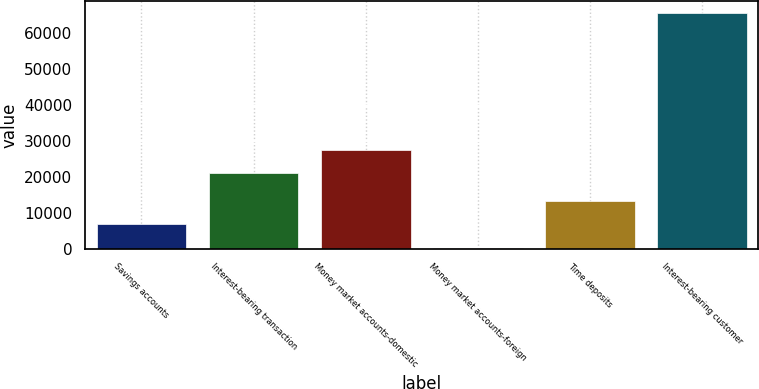Convert chart. <chart><loc_0><loc_0><loc_500><loc_500><bar_chart><fcel>Savings accounts<fcel>Interest-bearing transaction<fcel>Money market accounts-domestic<fcel>Money market accounts-foreign<fcel>Time deposits<fcel>Interest-bearing customer<nl><fcel>6831<fcel>21096<fcel>27616<fcel>311<fcel>13443<fcel>65511<nl></chart> 